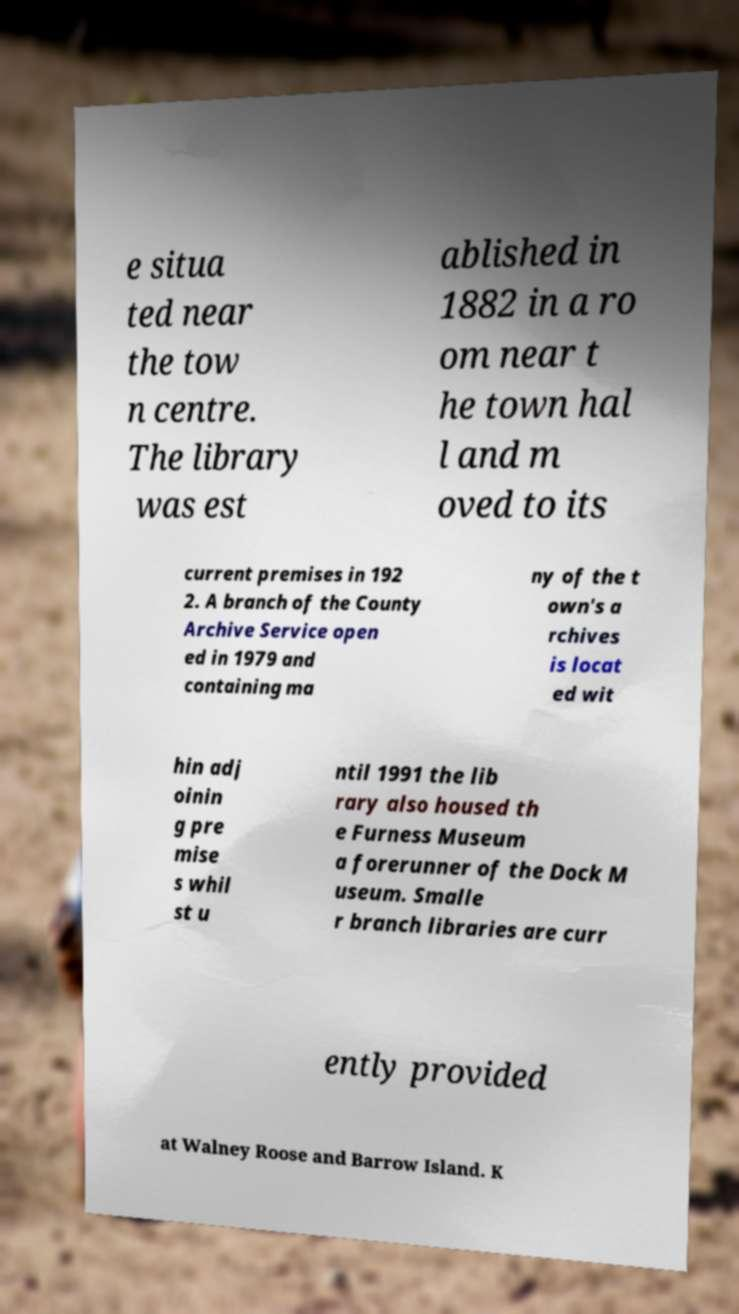Please identify and transcribe the text found in this image. e situa ted near the tow n centre. The library was est ablished in 1882 in a ro om near t he town hal l and m oved to its current premises in 192 2. A branch of the County Archive Service open ed in 1979 and containing ma ny of the t own's a rchives is locat ed wit hin adj oinin g pre mise s whil st u ntil 1991 the lib rary also housed th e Furness Museum a forerunner of the Dock M useum. Smalle r branch libraries are curr ently provided at Walney Roose and Barrow Island. K 